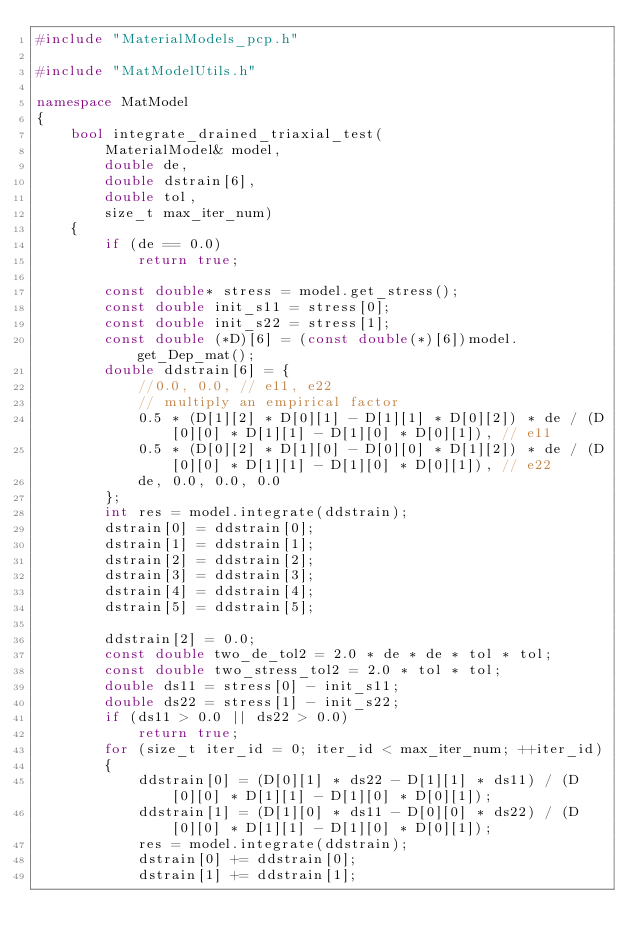Convert code to text. <code><loc_0><loc_0><loc_500><loc_500><_C++_>#include "MaterialModels_pcp.h"

#include "MatModelUtils.h"

namespace MatModel
{
	bool integrate_drained_triaxial_test(
		MaterialModel& model,
		double de,
		double dstrain[6],
		double tol,
		size_t max_iter_num)
	{
		if (de == 0.0)
			return true;

		const double* stress = model.get_stress();
		const double init_s11 = stress[0];
		const double init_s22 = stress[1];
		const double (*D)[6] = (const double(*)[6])model.get_Dep_mat();
		double ddstrain[6] = {
			//0.0, 0.0, // e11, e22
			// multiply an empirical factor
			0.5 * (D[1][2] * D[0][1] - D[1][1] * D[0][2]) * de / (D[0][0] * D[1][1] - D[1][0] * D[0][1]), // e11
			0.5 * (D[0][2] * D[1][0] - D[0][0] * D[1][2]) * de / (D[0][0] * D[1][1] - D[1][0] * D[0][1]), // e22
			de,	0.0, 0.0, 0.0
		};
		int res = model.integrate(ddstrain);
		dstrain[0] = ddstrain[0];
		dstrain[1] = ddstrain[1];
		dstrain[2] = ddstrain[2];
		dstrain[3] = ddstrain[3];
		dstrain[4] = ddstrain[4];
		dstrain[5] = ddstrain[5];

		ddstrain[2] = 0.0;
		const double two_de_tol2 = 2.0 * de * de * tol * tol;
		const double two_stress_tol2 = 2.0 * tol * tol;
		double ds11 = stress[0] - init_s11;
		double ds22 = stress[1] - init_s22;
		if (ds11 > 0.0 || ds22 > 0.0)
			return true;
		for (size_t iter_id = 0; iter_id < max_iter_num; ++iter_id)
		{
			ddstrain[0] = (D[0][1] * ds22 - D[1][1] * ds11) / (D[0][0] * D[1][1] - D[1][0] * D[0][1]);
			ddstrain[1] = (D[1][0] * ds11 - D[0][0] * ds22) / (D[0][0] * D[1][1] - D[1][0] * D[0][1]);
			res = model.integrate(ddstrain);
			dstrain[0] += ddstrain[0];
			dstrain[1] += ddstrain[1];</code> 